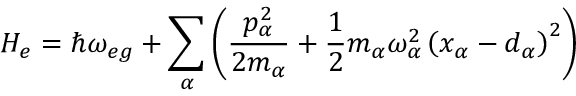<formula> <loc_0><loc_0><loc_500><loc_500>H _ { e } = \hbar { \omega } _ { e g } + \sum _ { \alpha } \left ( \frac { p _ { \alpha } ^ { 2 } } { 2 m _ { \alpha } } + \frac { 1 } { 2 } m _ { \alpha } \omega _ { \alpha } ^ { 2 } \left ( x _ { \alpha } - d _ { \alpha } \right ) ^ { 2 } \right )</formula> 